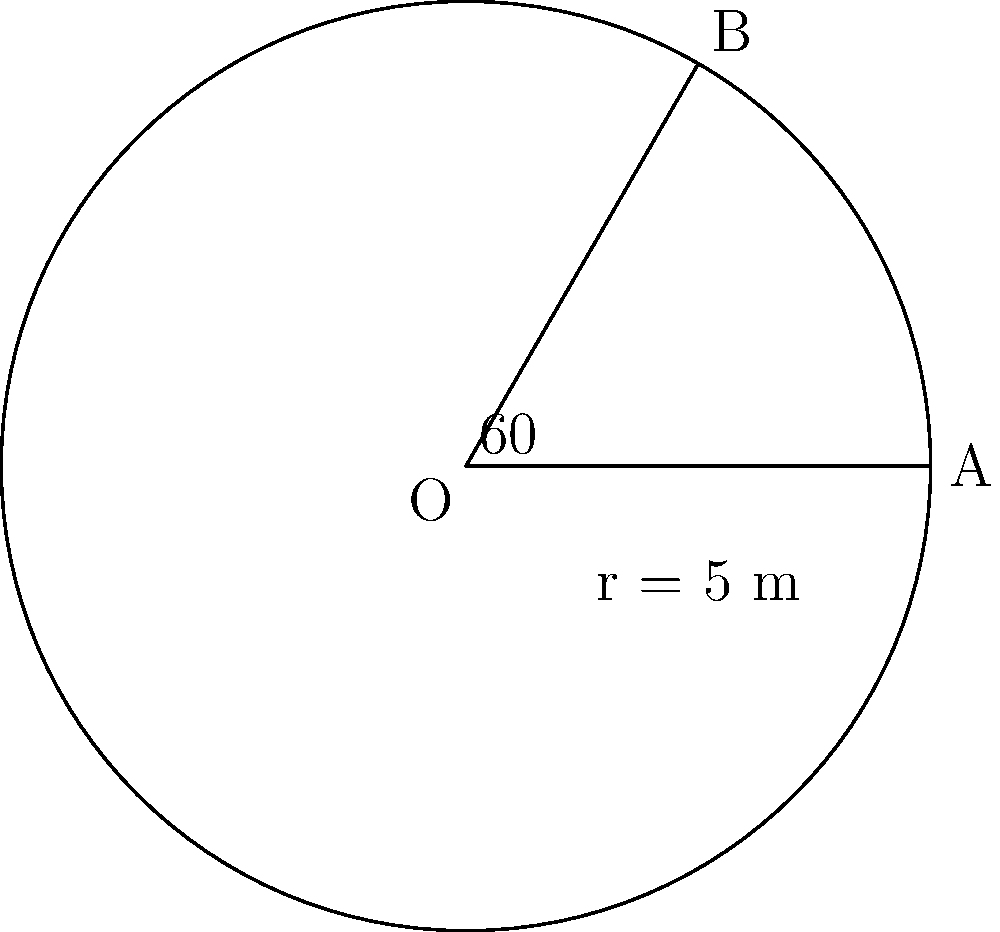In a chemical processing plant, you're designing a circular pipeline with a radius of 5 meters. A section of the pipeline forms an arc with a central angle of 60°. Calculate the length of this arc to determine the amount of specialized coating needed for this section. Express your answer in meters, rounded to two decimal places. To solve this problem, we'll use the formula for arc length in a circle:

$$ s = r\theta $$

Where:
$s$ = arc length
$r$ = radius of the circle
$\theta$ = central angle in radians

Step 1: Convert the central angle from degrees to radians.
$$ \theta = 60° \times \frac{\pi}{180°} = \frac{\pi}{3} \text{ radians} $$

Step 2: Apply the arc length formula.
$$ s = r\theta = 5 \text{ m} \times \frac{\pi}{3} $$

Step 3: Simplify and calculate.
$$ s = \frac{5\pi}{3} \text{ m} $$

Step 4: Evaluate and round to two decimal places.
$$ s \approx 5.24 \text{ m} $$

Therefore, the length of the arc is approximately 5.24 meters.
Answer: 5.24 m 